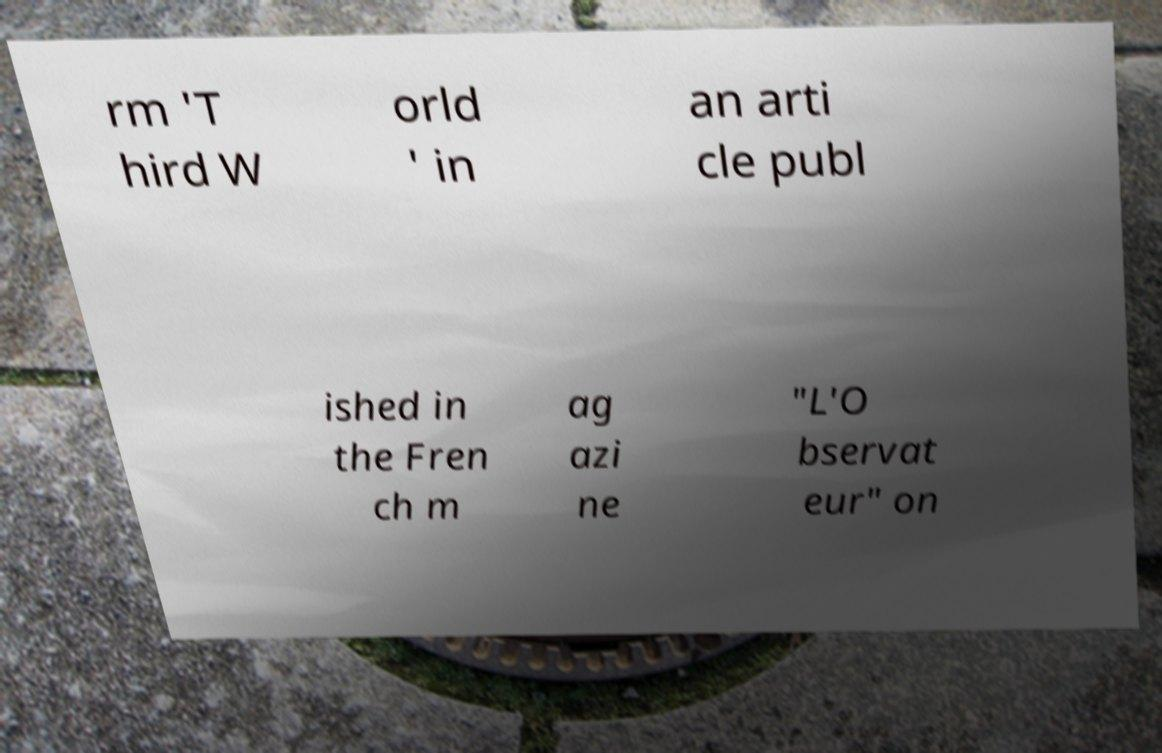There's text embedded in this image that I need extracted. Can you transcribe it verbatim? rm 'T hird W orld ' in an arti cle publ ished in the Fren ch m ag azi ne "L'O bservat eur" on 